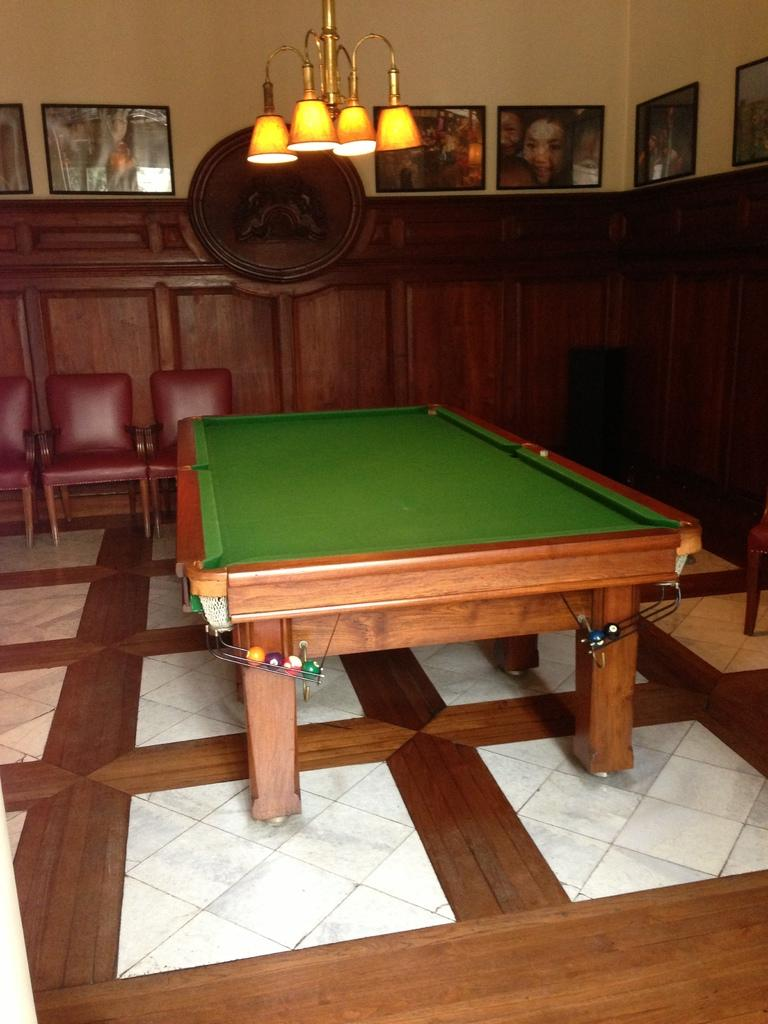What color is the wall that is visible in the image? The wall in the image is yellow. What is hanging on the wall in the image? There are frames on the wall in the image. What is located on the top of the wall in the image? There is a light on the top of the wall in the image. What type of furniture is on the floor in the image? There are chairs on the floor in the image. What type of game can be played on the board that is on the floor in the image? There is a billiards board on the floor in the image, which is used for playing billiards. Reasoning: Let' Let's think step by step in order to produce the conversation. We start by identifying the main subject in the image, which is the yellow wall. Then, we expand the conversation to include other items that are also visible, such as the frames, light, chairs, and billiards board. Each question is designed question is designed to elicit a specific detail about the image that is known from the provided facts. Absurd Question/Answer: What type of church can be seen in the image? There is no church present in the image; it features a yellow wall with frames, a light, chairs, and a billiards board. What angle is the volcano erupting at in the image? There is no volcano present in the image; it features a yellow wall with frames, a light, chairs, and a billiards board. What type of church can be seen in the image? There is no church present in the image; it features a yellow wall with frames, a light, chairs, and a billiards board. What angle is the volcano erupting at in the image? There is no volcano present in the image; it features a yellow wall with frames, a light, chairs, and a billiards board. 